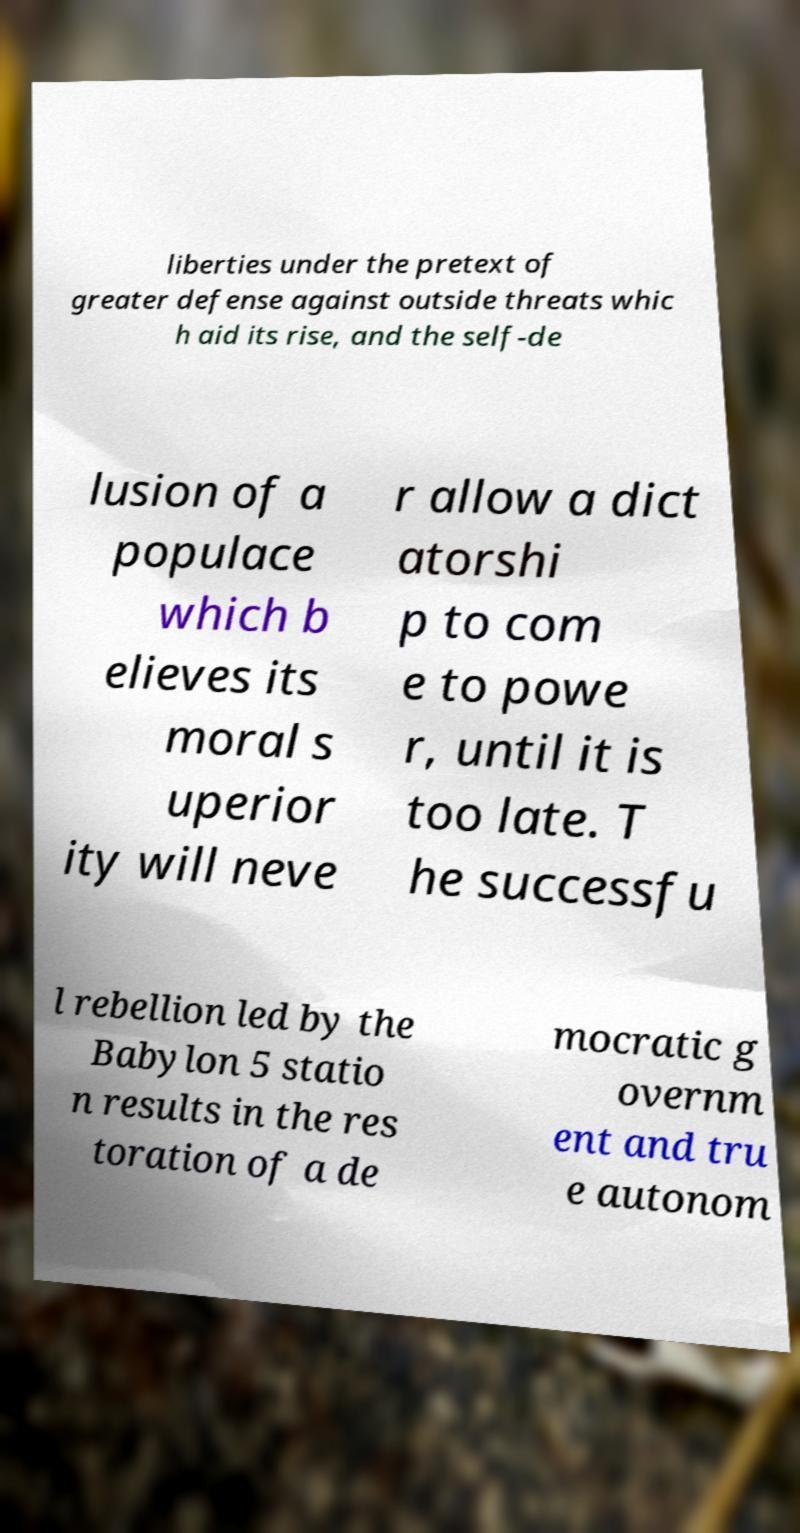For documentation purposes, I need the text within this image transcribed. Could you provide that? liberties under the pretext of greater defense against outside threats whic h aid its rise, and the self-de lusion of a populace which b elieves its moral s uperior ity will neve r allow a dict atorshi p to com e to powe r, until it is too late. T he successfu l rebellion led by the Babylon 5 statio n results in the res toration of a de mocratic g overnm ent and tru e autonom 